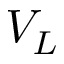Convert formula to latex. <formula><loc_0><loc_0><loc_500><loc_500>V _ { L }</formula> 